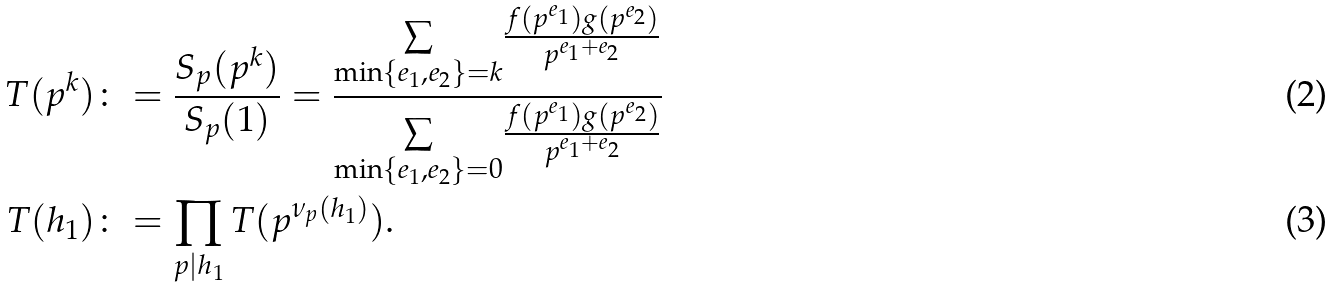Convert formula to latex. <formula><loc_0><loc_0><loc_500><loc_500>T ( p ^ { k } ) & \colon = \frac { S _ { p } ( p ^ { k } ) } { S _ { p } ( 1 ) } = \frac { \underset { \min \{ e _ { 1 } , e _ { 2 } \} = k } { \sum } \frac { f ( p ^ { e _ { 1 } } ) g ( p ^ { e _ { 2 } } ) } { p ^ { e _ { 1 } + e _ { 2 } } } } { \underset { \min \{ e _ { 1 } , e _ { 2 } \} = 0 } { \sum } \frac { f ( p ^ { e _ { 1 } } ) g ( p ^ { e _ { 2 } } ) } { p ^ { e _ { 1 } + e _ { 2 } } } } \\ T ( h _ { 1 } ) & \colon = \prod _ { p | h _ { 1 } } T ( p ^ { \nu _ { p } ( h _ { 1 } ) } ) .</formula> 